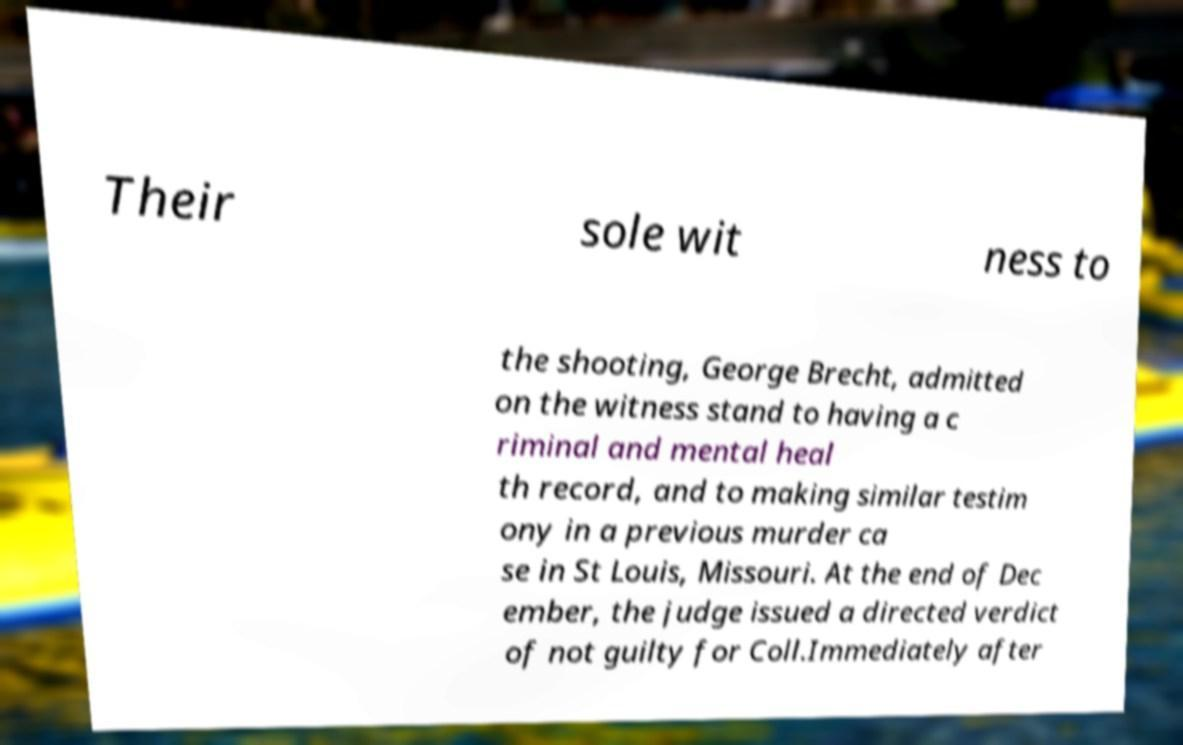For documentation purposes, I need the text within this image transcribed. Could you provide that? Their sole wit ness to the shooting, George Brecht, admitted on the witness stand to having a c riminal and mental heal th record, and to making similar testim ony in a previous murder ca se in St Louis, Missouri. At the end of Dec ember, the judge issued a directed verdict of not guilty for Coll.Immediately after 